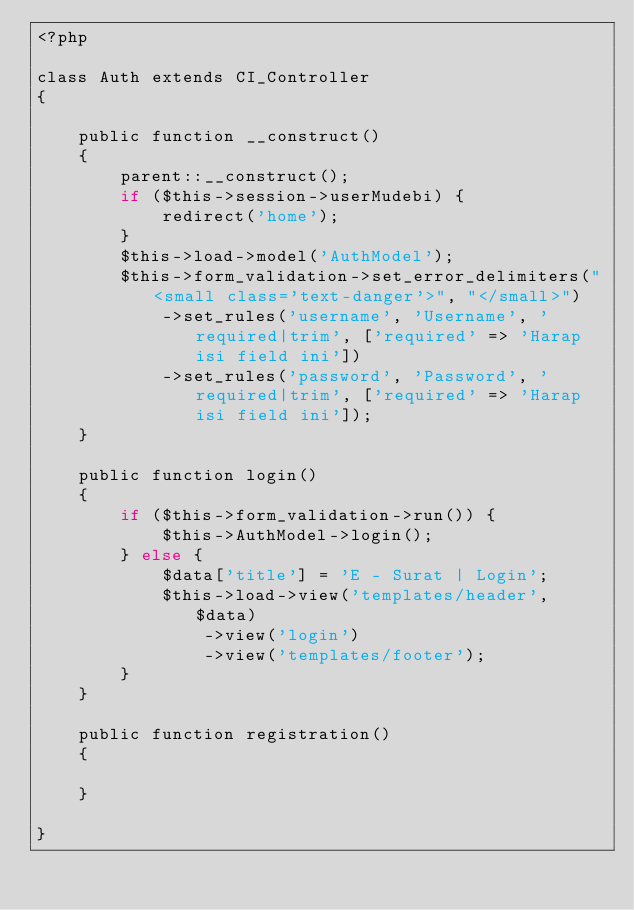<code> <loc_0><loc_0><loc_500><loc_500><_PHP_><?php

class Auth extends CI_Controller
{

	public function __construct()
	{
		parent::__construct();
		if ($this->session->userMudebi) {
			redirect('home');
		}
		$this->load->model('AuthModel');
		$this->form_validation->set_error_delimiters("<small class='text-danger'>", "</small>")
			->set_rules('username', 'Username', 'required|trim', ['required' => 'Harap isi field ini'])
			->set_rules('password', 'Password', 'required|trim', ['required' => 'Harap isi field ini']);
	}

	public function login()
	{
		if ($this->form_validation->run()) {
			$this->AuthModel->login();
		} else {
			$data['title'] = 'E - Surat | Login';
			$this->load->view('templates/header', $data)
				->view('login')
				->view('templates/footer');
		}
	}

	public function registration()
	{
		
	}

}
</code> 